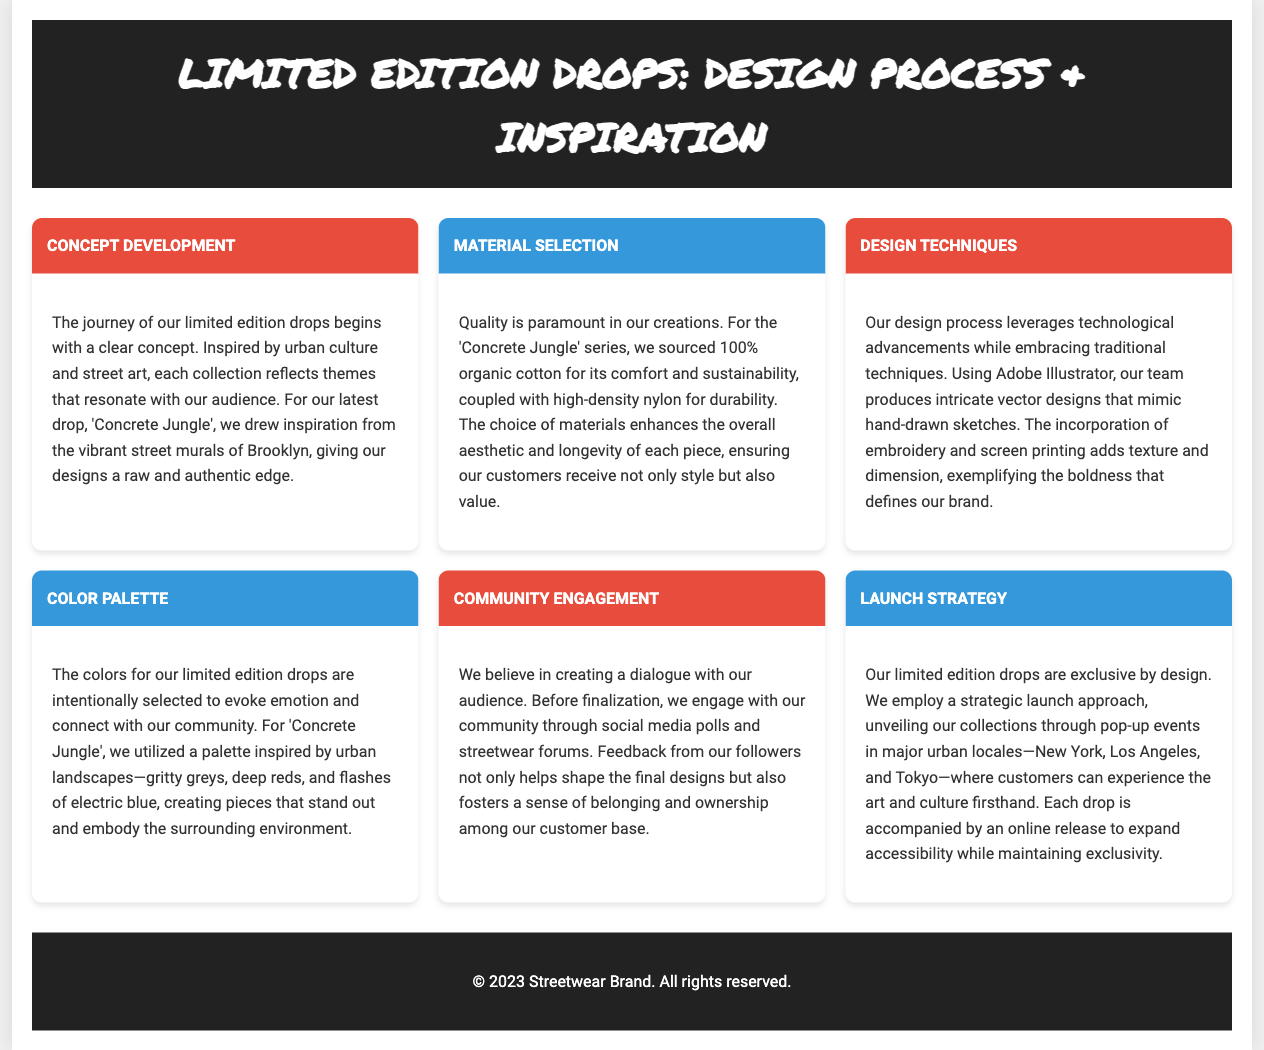what is the latest drop's title? The title of the latest drop is mentioned as 'Concrete Jungle' in the document.
Answer: Concrete Jungle what material is used for the 'Concrete Jungle' series? The document specifies that the material used is 100% organic cotton.
Answer: 100% organic cotton what design software is mentioned in the document? The document states that Adobe Illustrator is used for producing intricate vector designs.
Answer: Adobe Illustrator which cities are included in the launch strategy for the limited edition drops? The launch strategy mentions three urban locales: New York, Los Angeles, and Tokyo.
Answer: New York, Los Angeles, and Tokyo what inspires the color palette for the latest drop? The color palette is inspired by urban landscapes, as stated in the document.
Answer: Urban landscapes how does the brand engage with the community regarding design feedback? According to the document, the brand engages with the community through social media polls.
Answer: Social media polls what is the main focus of the concept development for the limited edition drops? The main focus is to reflect themes that resonate with the audience, as mentioned in the document.
Answer: Themes that resonate with the audience what type of engagement is emphasized before finalizing designs? The document emphasizes community engagement through feedback before finalizing designs.
Answer: Feedback which design technique adds texture and dimension to the pieces? The document mentions that embroidery and screen printing add texture and dimension.
Answer: Embroidery and screen printing 